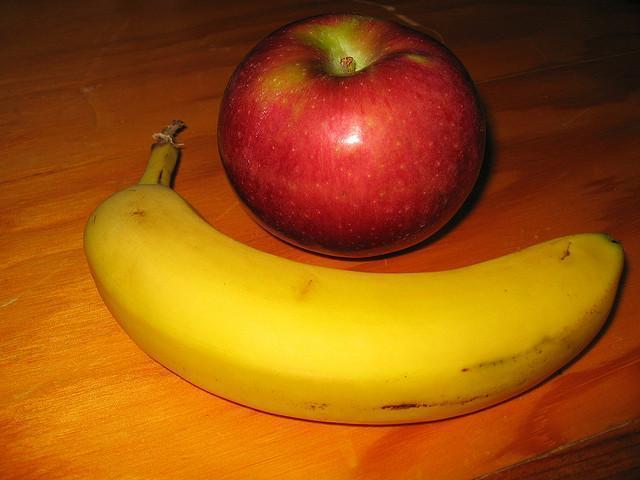How many bananas are there?
Give a very brief answer. 1. How many people are sitting on the bench?
Give a very brief answer. 0. 